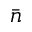<formula> <loc_0><loc_0><loc_500><loc_500>\bar { n }</formula> 